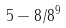Convert formula to latex. <formula><loc_0><loc_0><loc_500><loc_500>5 - 8 / 8 ^ { 9 }</formula> 